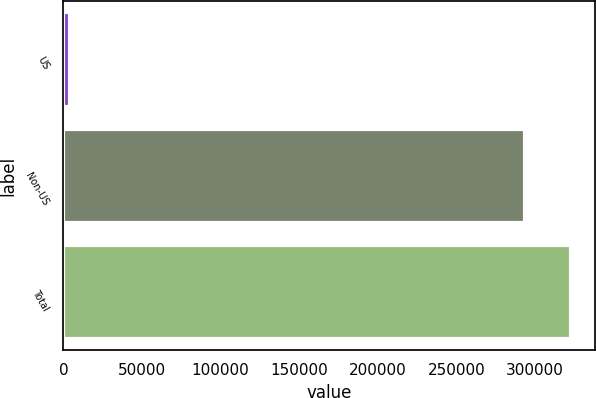Convert chart to OTSL. <chart><loc_0><loc_0><loc_500><loc_500><bar_chart><fcel>US<fcel>Non-US<fcel>Total<nl><fcel>3743<fcel>292975<fcel>322272<nl></chart> 